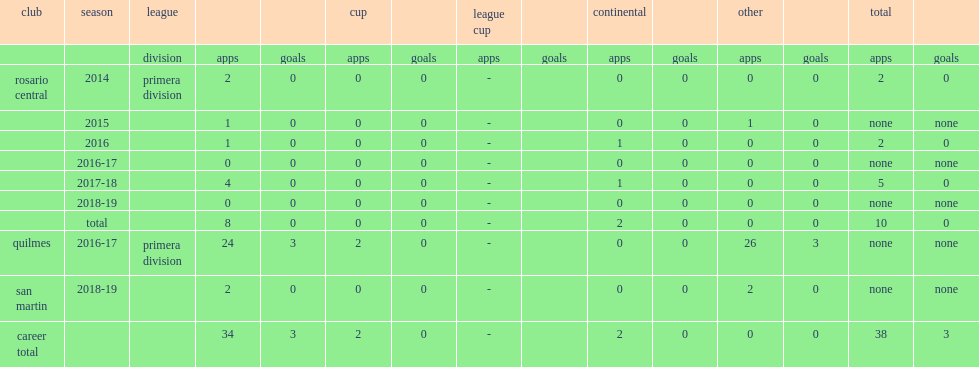Could you parse the entire table? {'header': ['club', 'season', 'league', '', '', 'cup', '', 'league cup', '', 'continental', '', 'other', '', 'total', ''], 'rows': [['', '', 'division', 'apps', 'goals', 'apps', 'goals', 'apps', 'goals', 'apps', 'goals', 'apps', 'goals', 'apps', 'goals'], ['rosario central', '2014', 'primera division', '2', '0', '0', '0', '-', '', '0', '0', '0', '0', '2', '0'], ['', '2015', '', '1', '0', '0', '0', '-', '', '0', '0', '1', '0', 'none', 'none'], ['', '2016', '', '1', '0', '0', '0', '-', '', '1', '0', '0', '0', '2', '0'], ['', '2016-17', '', '0', '0', '0', '0', '-', '', '0', '0', '0', '0', 'none', 'none'], ['', '2017-18', '', '4', '0', '0', '0', '-', '', '1', '0', '0', '0', '5', '0'], ['', '2018-19', '', '0', '0', '0', '0', '-', '', '0', '0', '0', '0', 'none', 'none'], ['', 'total', '', '8', '0', '0', '0', '-', '', '2', '0', '0', '0', '10', '0'], ['quilmes', '2016-17', 'primera division', '24', '3', '2', '0', '-', '', '0', '0', '26', '3', 'none', 'none'], ['san martin', '2018-19', '', '2', '0', '0', '0', '-', '', '0', '0', '2', '0', 'none', 'none'], ['career total', '', '', '34', '3', '2', '0', '-', '', '2', '0', '0', '0', '38', '3']]} Which division did da campo debute in for rosario central in 2014? Primera division. 